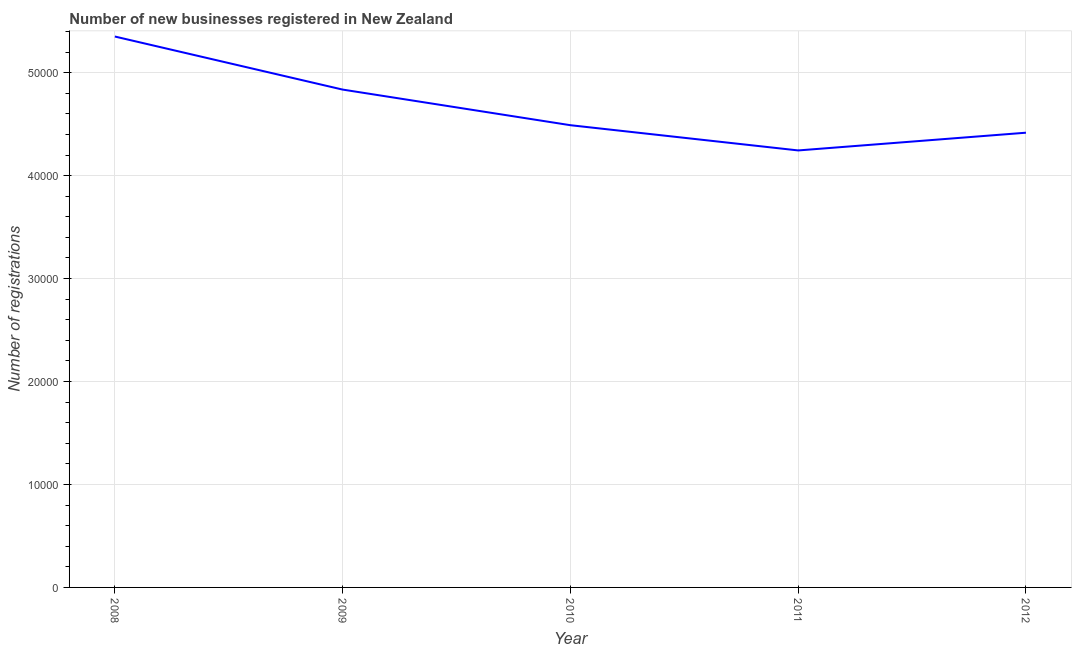What is the number of new business registrations in 2010?
Make the answer very short. 4.49e+04. Across all years, what is the maximum number of new business registrations?
Offer a very short reply. 5.35e+04. Across all years, what is the minimum number of new business registrations?
Offer a very short reply. 4.24e+04. What is the sum of the number of new business registrations?
Your answer should be very brief. 2.33e+05. What is the difference between the number of new business registrations in 2008 and 2009?
Make the answer very short. 5154. What is the average number of new business registrations per year?
Offer a terse response. 4.67e+04. What is the median number of new business registrations?
Give a very brief answer. 4.49e+04. What is the ratio of the number of new business registrations in 2009 to that in 2010?
Give a very brief answer. 1.08. Is the difference between the number of new business registrations in 2008 and 2010 greater than the difference between any two years?
Keep it short and to the point. No. What is the difference between the highest and the second highest number of new business registrations?
Give a very brief answer. 5154. What is the difference between the highest and the lowest number of new business registrations?
Your response must be concise. 1.11e+04. In how many years, is the number of new business registrations greater than the average number of new business registrations taken over all years?
Your answer should be very brief. 2. How many years are there in the graph?
Ensure brevity in your answer.  5. Does the graph contain any zero values?
Make the answer very short. No. What is the title of the graph?
Provide a succinct answer. Number of new businesses registered in New Zealand. What is the label or title of the Y-axis?
Provide a succinct answer. Number of registrations. What is the Number of registrations in 2008?
Your answer should be compact. 5.35e+04. What is the Number of registrations of 2009?
Provide a short and direct response. 4.84e+04. What is the Number of registrations of 2010?
Give a very brief answer. 4.49e+04. What is the Number of registrations in 2011?
Offer a terse response. 4.24e+04. What is the Number of registrations of 2012?
Make the answer very short. 4.42e+04. What is the difference between the Number of registrations in 2008 and 2009?
Your answer should be very brief. 5154. What is the difference between the Number of registrations in 2008 and 2010?
Keep it short and to the point. 8614. What is the difference between the Number of registrations in 2008 and 2011?
Offer a very short reply. 1.11e+04. What is the difference between the Number of registrations in 2008 and 2012?
Give a very brief answer. 9343. What is the difference between the Number of registrations in 2009 and 2010?
Make the answer very short. 3460. What is the difference between the Number of registrations in 2009 and 2011?
Provide a succinct answer. 5911. What is the difference between the Number of registrations in 2009 and 2012?
Give a very brief answer. 4189. What is the difference between the Number of registrations in 2010 and 2011?
Your response must be concise. 2451. What is the difference between the Number of registrations in 2010 and 2012?
Your answer should be very brief. 729. What is the difference between the Number of registrations in 2011 and 2012?
Your response must be concise. -1722. What is the ratio of the Number of registrations in 2008 to that in 2009?
Your answer should be very brief. 1.11. What is the ratio of the Number of registrations in 2008 to that in 2010?
Offer a terse response. 1.19. What is the ratio of the Number of registrations in 2008 to that in 2011?
Make the answer very short. 1.26. What is the ratio of the Number of registrations in 2008 to that in 2012?
Offer a terse response. 1.21. What is the ratio of the Number of registrations in 2009 to that in 2010?
Your response must be concise. 1.08. What is the ratio of the Number of registrations in 2009 to that in 2011?
Offer a very short reply. 1.14. What is the ratio of the Number of registrations in 2009 to that in 2012?
Provide a short and direct response. 1.09. What is the ratio of the Number of registrations in 2010 to that in 2011?
Keep it short and to the point. 1.06. What is the ratio of the Number of registrations in 2011 to that in 2012?
Offer a very short reply. 0.96. 